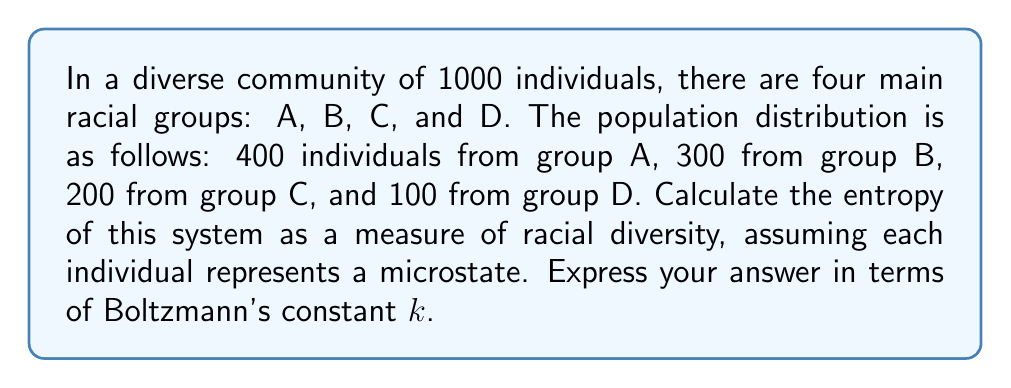Provide a solution to this math problem. To calculate the entropy of this system, we'll use the Boltzmann entropy formula:

$$S = k \ln W$$

where $S$ is entropy, $k$ is Boltzmann's constant, and $W$ is the number of microstates.

In this case, we need to calculate the number of ways to arrange the individuals in the community. This is a multinomial distribution problem.

1) The number of microstates $W$ is given by:

   $$W = \frac{N!}{N_A! N_B! N_C! N_D!}$$

   where $N$ is the total population, and $N_A$, $N_B$, $N_C$, and $N_D$ are the populations of each group.

2) Substituting the values:

   $$W = \frac{1000!}{400! 300! 200! 100!}$$

3) This number is extremely large, so we'll use Stirling's approximation: $\ln(n!) \approx n \ln(n) - n$

4) Applying this to our entropy formula:

   $$\begin{align}
   S &= k \ln W \\
   &= k \ln \frac{1000!}{400! 300! 200! 100!} \\
   &= k [1000 \ln(1000) - 1000 - (400 \ln(400) - 400 + 300 \ln(300) - 300 + 200 \ln(200) - 200 + 100 \ln(100) - 100)]
   \end{align}$$

5) Simplifying:

   $$S = k [1000 \ln(1000) - 400 \ln(400) - 300 \ln(300) - 200 \ln(200) - 100 \ln(100)]$$

6) Calculating the numerical values:

   $$S = k [6907.76 - 2390.10 - 1702.65 - 1060.20 - 460.52]$$

7) Final result:

   $$S = 1294.29k$$

This value represents the entropy of the system, which is a measure of the racial diversity in the community.
Answer: $1294.29k$ 